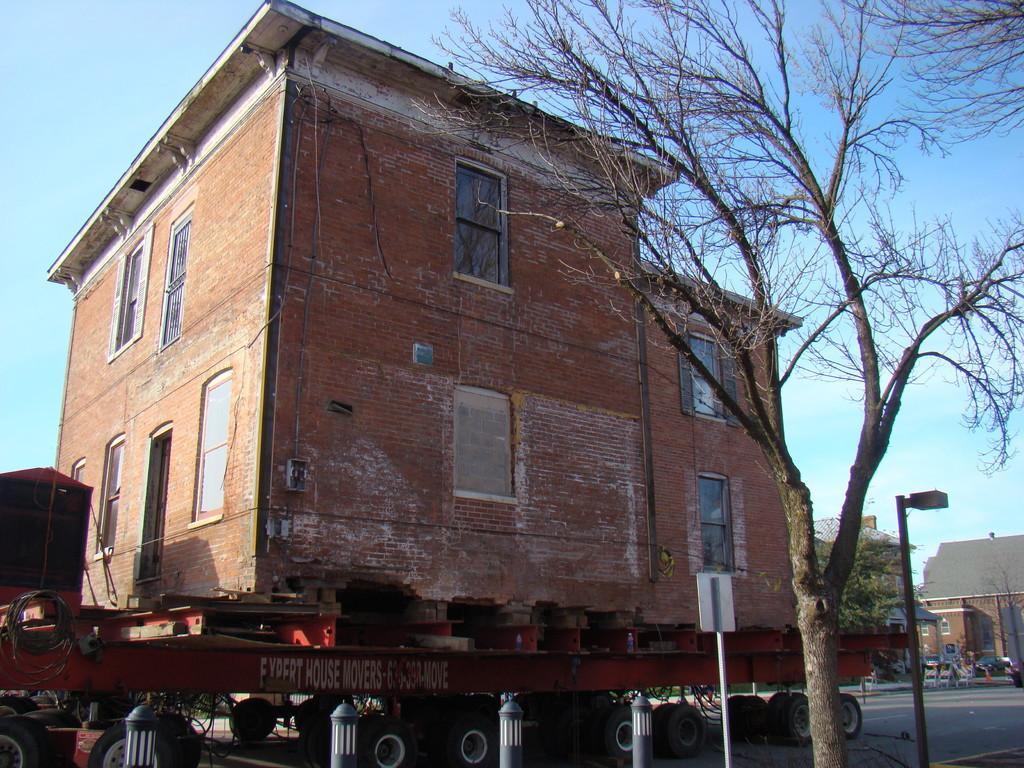Describe this image in one or two sentences. In this picture we can see a building on a vehicle and the vehicle is on the road. In front of the building there is a tree and poles with a light and a board. On the right side of the building there are trees, a vehicle, buildings and the sky. 